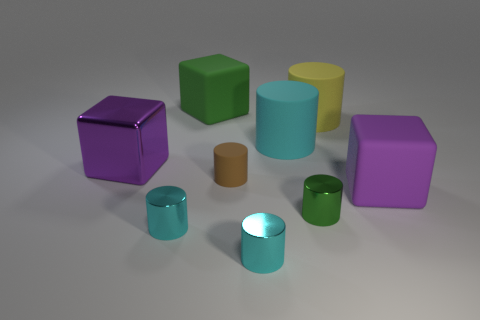Subtract all green rubber cubes. How many cubes are left? 2 Add 1 large cylinders. How many objects exist? 10 Subtract all purple blocks. How many blocks are left? 1 Subtract 1 cylinders. How many cylinders are left? 5 Subtract all gray cubes. Subtract all cyan spheres. How many cubes are left? 3 Subtract all red cylinders. How many green cubes are left? 1 Subtract all small cyan metal cylinders. Subtract all big green rubber objects. How many objects are left? 6 Add 9 green blocks. How many green blocks are left? 10 Add 9 purple matte cubes. How many purple matte cubes exist? 10 Subtract 0 brown spheres. How many objects are left? 9 